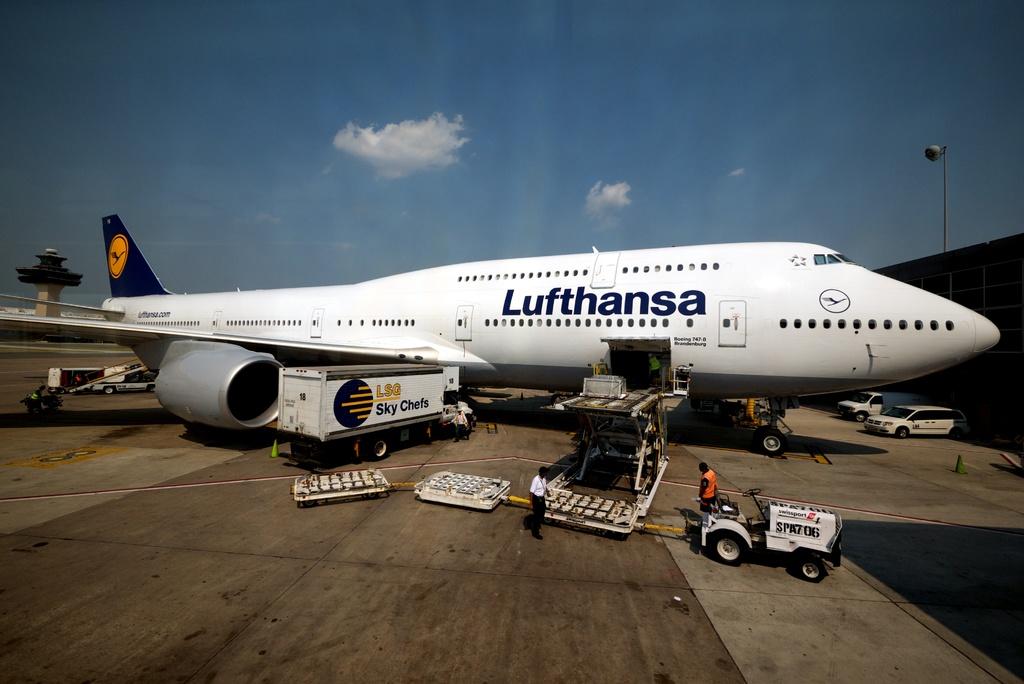What airline is the plane from?
Your answer should be compact. Lufthansa. 